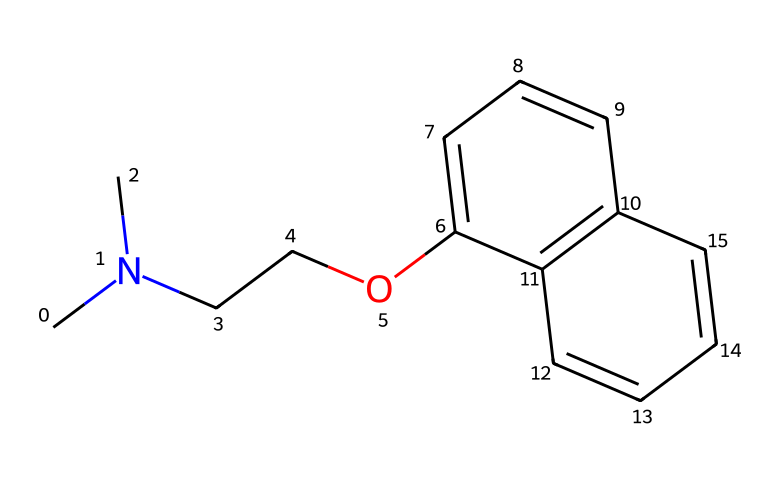What is the molecular formula of this compound? To find the molecular formula, we need to count the number of each type of atom in the chemical structure. The SMILES representation indicates there are 13 carbon (C) atoms, 15 hydrogen (H) atoms, and 1 nitrogen (N) atom. Therefore, the molecular formula is C13H15N.
Answer: C13H15N How many rings are present in the structure? By analyzing the chemical structure, we can observe that there are two interconnected rings, which is common in certain classes of drugs, especially antidepressants. The presence of two distinct cycles can be counted visually.
Answer: 2 What functional group is indicated by the presence of nitrogen? The presence of a nitrogen atom in the structure suggests that the compound is a tertiary amine. This functional group typically has significant roles in biological activity, particularly in neurotransmitter modulation.
Answer: tertiary amine What type of antidepressant is this compound likely to be based on its structure? The structure resembles that of SSRIs, which are selective serotonin reuptake inhibitors. The carbon structure with a nitrogen atom and rings aligns with known SSRIs that primarily affect serotonin levels in the brain.
Answer: SSRI How does the structure suggest its role as a serotonin transporter inhibitor? The presence of specific functional groups and the overall configuration of the cyclic structure fit into the molecular designs of known serotonin transporter inhibitors, which have been identified to interact with serotonin reuptake mechanisms. This compound has a structure that supports such interactions.
Answer: It suggests inhibition 